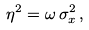Convert formula to latex. <formula><loc_0><loc_0><loc_500><loc_500>\eta ^ { 2 } = \omega \, \sigma _ { x } ^ { 2 } \, ,</formula> 